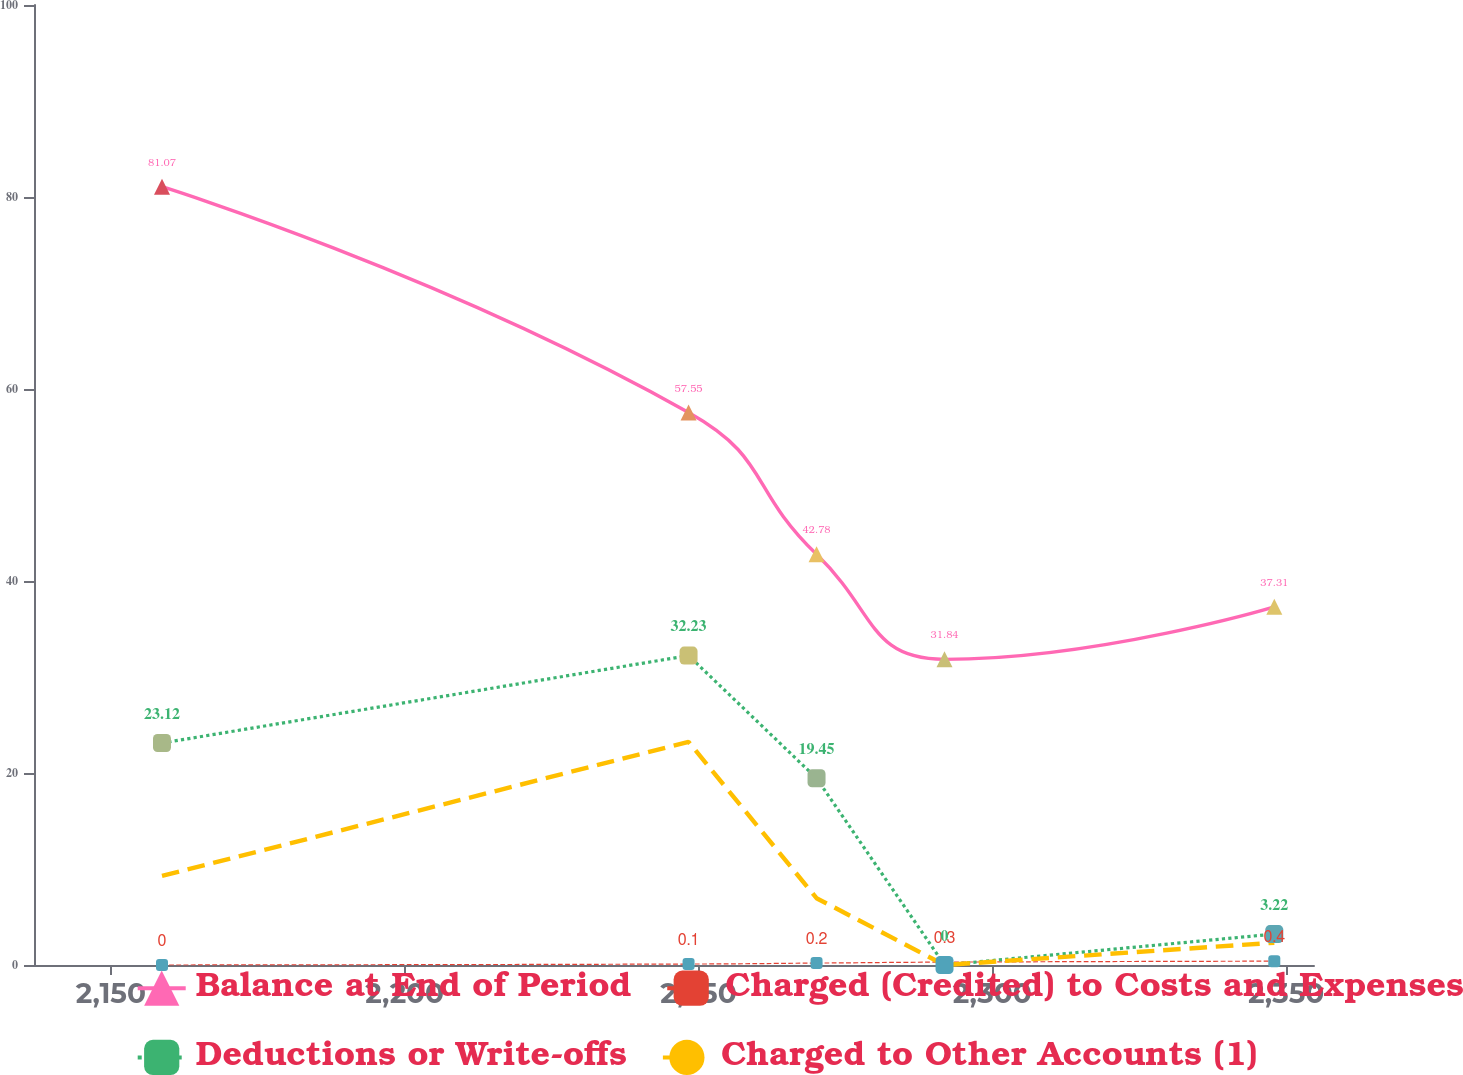<chart> <loc_0><loc_0><loc_500><loc_500><line_chart><ecel><fcel>Balance at End of Period<fcel>Charged (Credited) to Costs and Expenses<fcel>Deductions or Write-offs<fcel>Charged to Other Accounts (1)<nl><fcel>2158.7<fcel>81.07<fcel>0<fcel>23.12<fcel>9.28<nl><fcel>2248.31<fcel>57.55<fcel>0.1<fcel>32.23<fcel>23.24<nl><fcel>2270.09<fcel>42.78<fcel>0.2<fcel>19.45<fcel>6.96<nl><fcel>2291.87<fcel>31.84<fcel>0.3<fcel>0<fcel>0<nl><fcel>2347.99<fcel>37.31<fcel>0.4<fcel>3.22<fcel>2.32<nl><fcel>2376.53<fcel>26.37<fcel>0.5<fcel>6.44<fcel>4.64<nl></chart> 